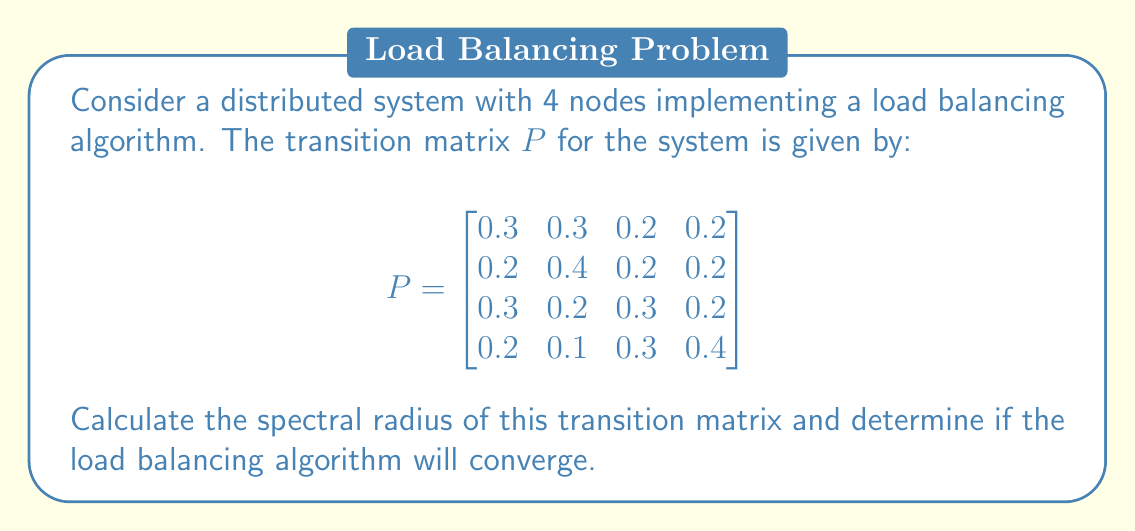Could you help me with this problem? To solve this problem, we'll follow these steps:

1) The spectral radius of a matrix is the largest absolute value of its eigenvalues. To find the eigenvalues, we need to solve the characteristic equation:

   $\det(P - \lambda I) = 0$

2) Expanding this determinant:

   $$\begin{vmatrix}
   0.3-\lambda & 0.3 & 0.2 & 0.2 \\
   0.2 & 0.4-\lambda & 0.2 & 0.2 \\
   0.3 & 0.2 & 0.3-\lambda & 0.2 \\
   0.2 & 0.1 & 0.3 & 0.4-\lambda
   \end{vmatrix} = 0$$

3) This yields the characteristic polynomial:

   $\lambda^4 - 1.4\lambda^3 + 0.5376\lambda^2 - 0.0704\lambda + 0.0028 = 0$

4) Solving this equation (using numerical methods, as it's a 4th degree polynomial) gives us the eigenvalues:

   $\lambda_1 = 1$
   $\lambda_2 \approx 0.2631$
   $\lambda_3 \approx 0.0685 + 0.0573i$
   $\lambda_4 \approx 0.0685 - 0.0573i$

5) The spectral radius is the maximum absolute value of these eigenvalues:

   $\rho(P) = \max(|\lambda_1|, |\lambda_2|, |\lambda_3|, |\lambda_4|) = 1$

6) For a load balancing algorithm to converge, the spectral radius must be less than or equal to 1. In this case, $\rho(P) = 1$, which is the boundary case.

7) However, for a stochastic matrix like this transition matrix (where each row sums to 1), having a spectral radius of 1 is expected and does not prevent convergence. The algorithm will converge to a stable distribution.
Answer: Spectral radius = 1; Algorithm converges 